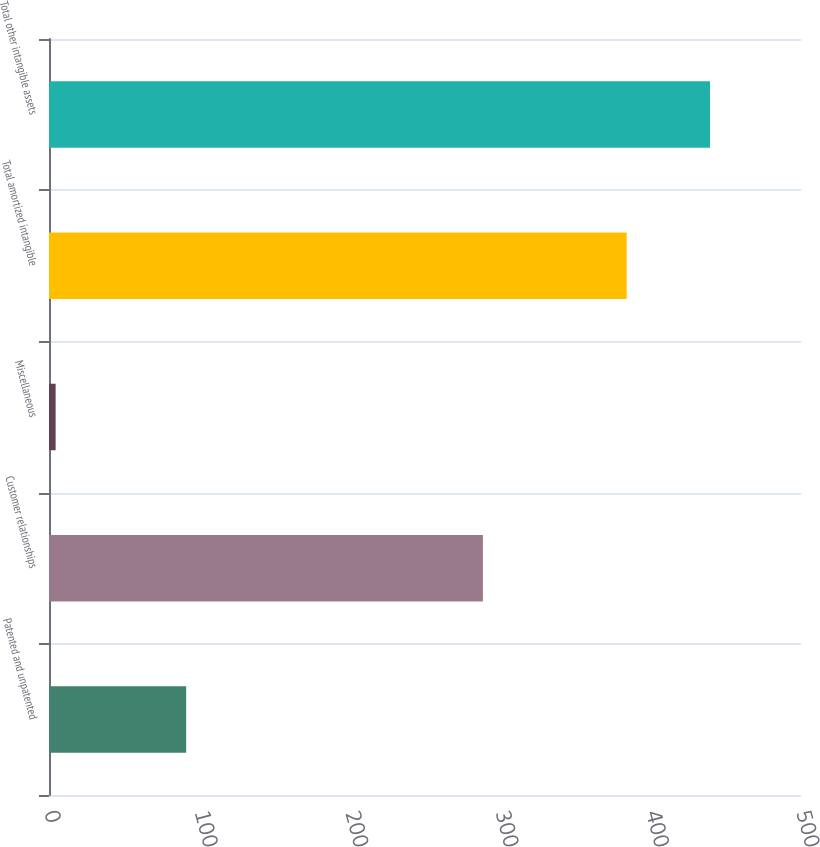Convert chart. <chart><loc_0><loc_0><loc_500><loc_500><bar_chart><fcel>Patented and unpatented<fcel>Customer relationships<fcel>Miscellaneous<fcel>Total amortized intangible<fcel>Total other intangible assets<nl><fcel>91.2<fcel>288.5<fcel>4.4<fcel>384.1<fcel>439.5<nl></chart> 